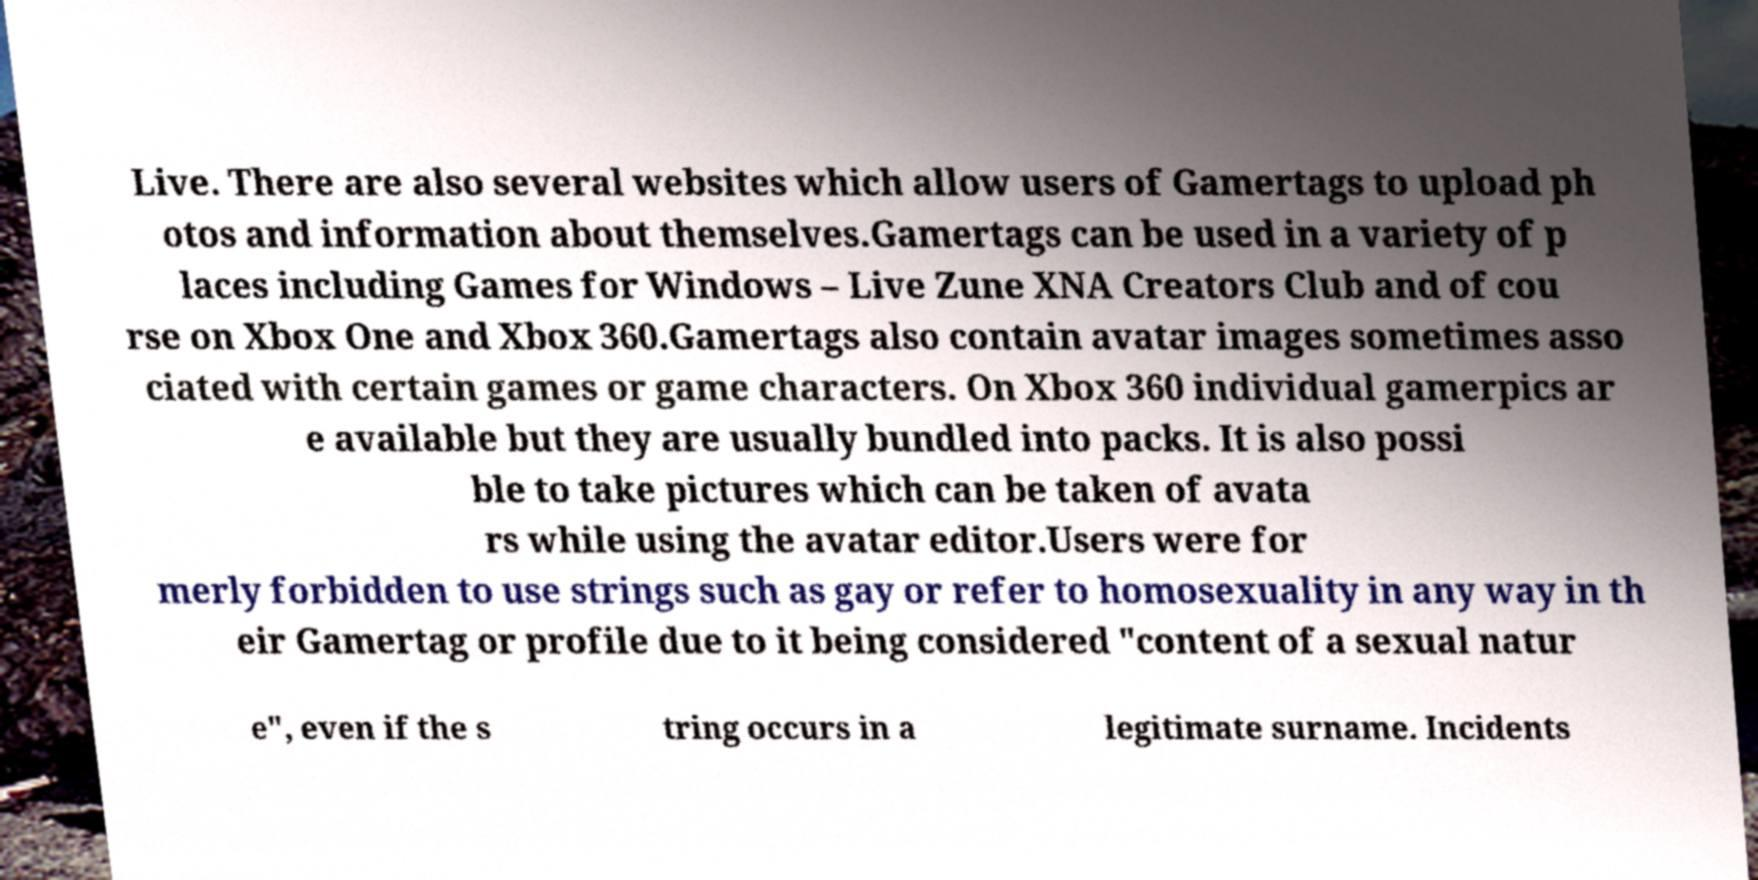I need the written content from this picture converted into text. Can you do that? Live. There are also several websites which allow users of Gamertags to upload ph otos and information about themselves.Gamertags can be used in a variety of p laces including Games for Windows – Live Zune XNA Creators Club and of cou rse on Xbox One and Xbox 360.Gamertags also contain avatar images sometimes asso ciated with certain games or game characters. On Xbox 360 individual gamerpics ar e available but they are usually bundled into packs. It is also possi ble to take pictures which can be taken of avata rs while using the avatar editor.Users were for merly forbidden to use strings such as gay or refer to homosexuality in any way in th eir Gamertag or profile due to it being considered "content of a sexual natur e", even if the s tring occurs in a legitimate surname. Incidents 